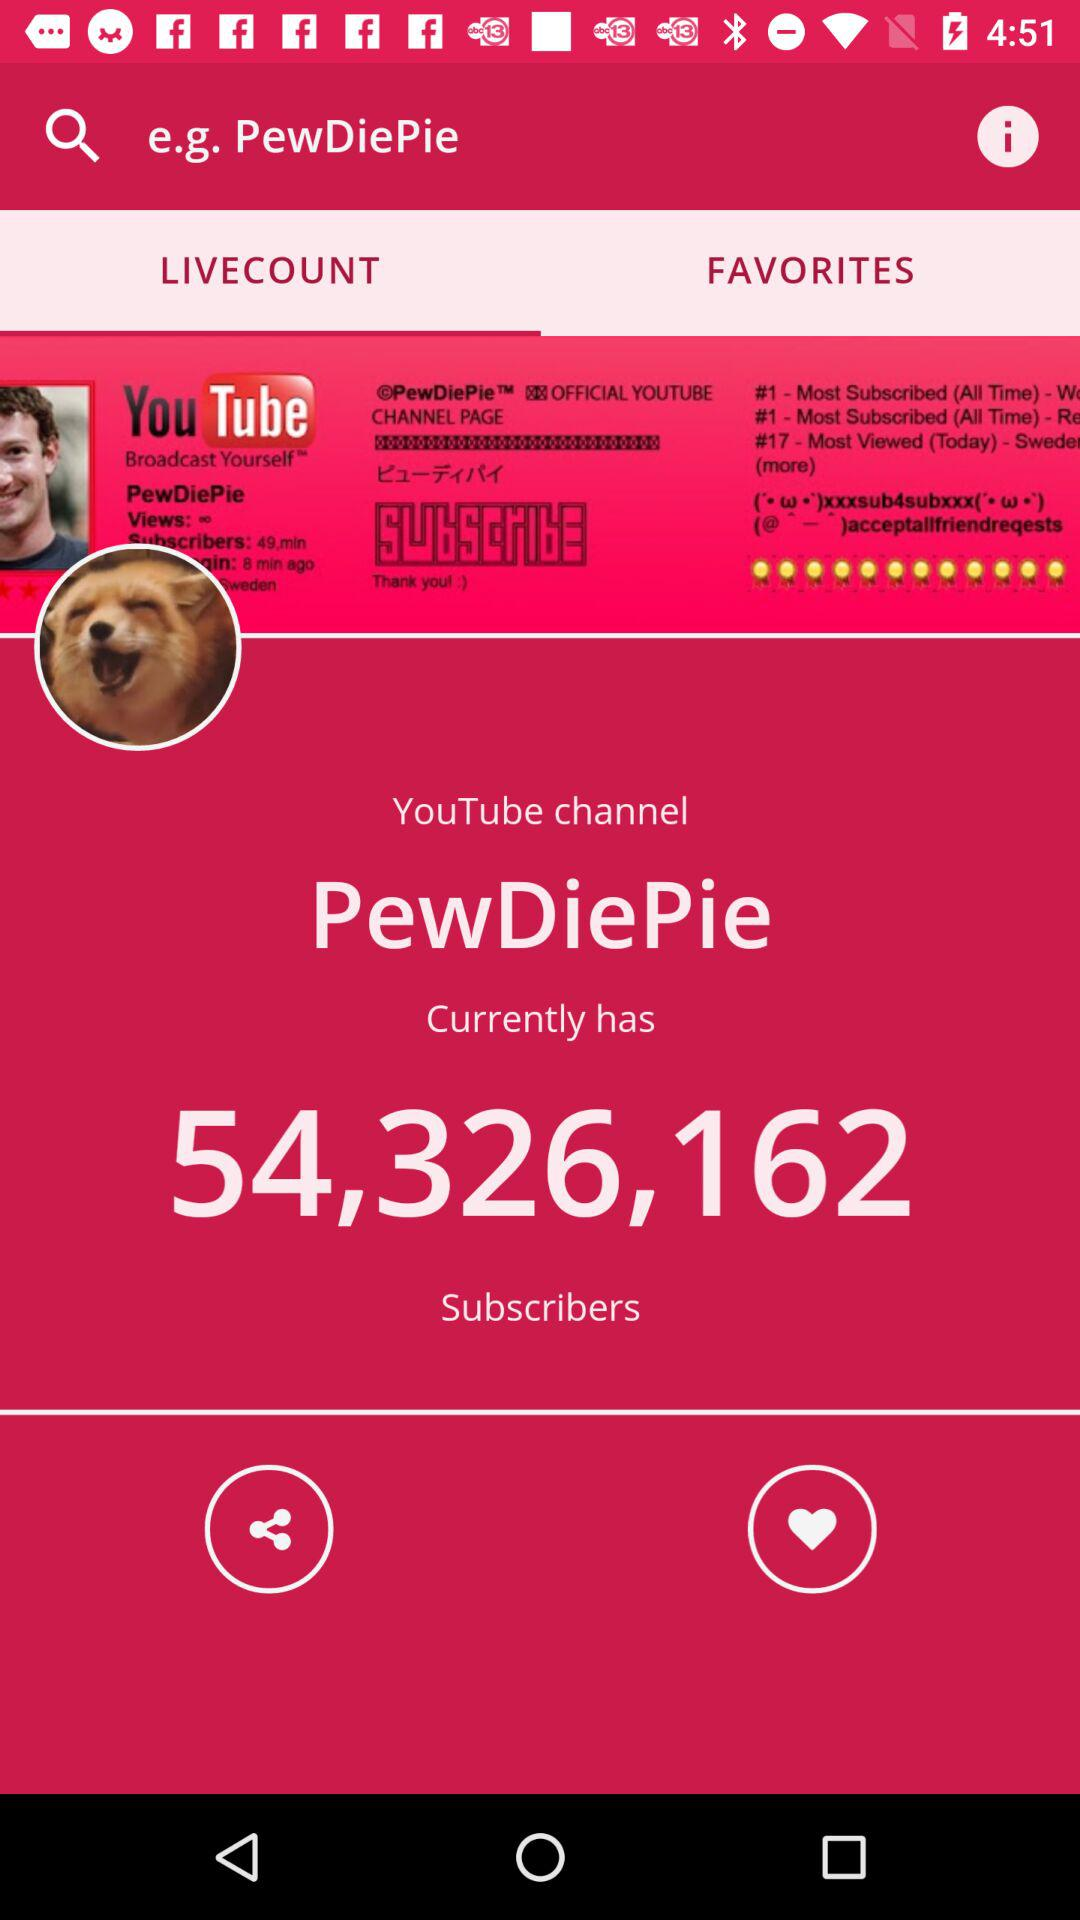Which tab is selected? The selected tab is "LIVECOUNT". 